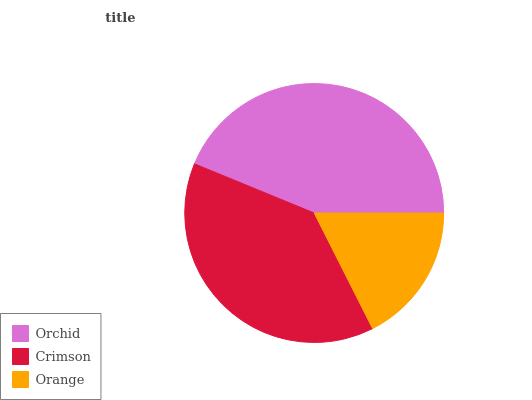Is Orange the minimum?
Answer yes or no. Yes. Is Orchid the maximum?
Answer yes or no. Yes. Is Crimson the minimum?
Answer yes or no. No. Is Crimson the maximum?
Answer yes or no. No. Is Orchid greater than Crimson?
Answer yes or no. Yes. Is Crimson less than Orchid?
Answer yes or no. Yes. Is Crimson greater than Orchid?
Answer yes or no. No. Is Orchid less than Crimson?
Answer yes or no. No. Is Crimson the high median?
Answer yes or no. Yes. Is Crimson the low median?
Answer yes or no. Yes. Is Orchid the high median?
Answer yes or no. No. Is Orange the low median?
Answer yes or no. No. 